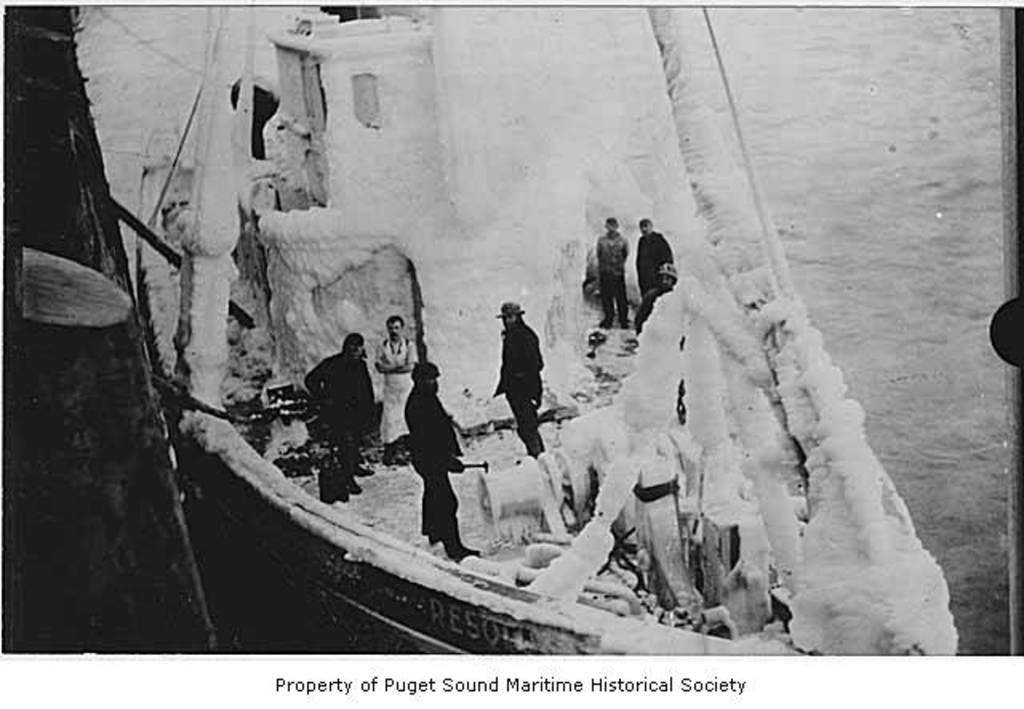What is the main subject of the image? The main subject of the image is persons on a boat. What can be seen in the background of the image? There is water visible in the image. Is there any text present in the image? Yes, there is text written at the bottom of the image. How many oranges are being held by the persons on the boat in the image? There is no mention of oranges in the image, so it cannot be determined how many oranges might be present. 